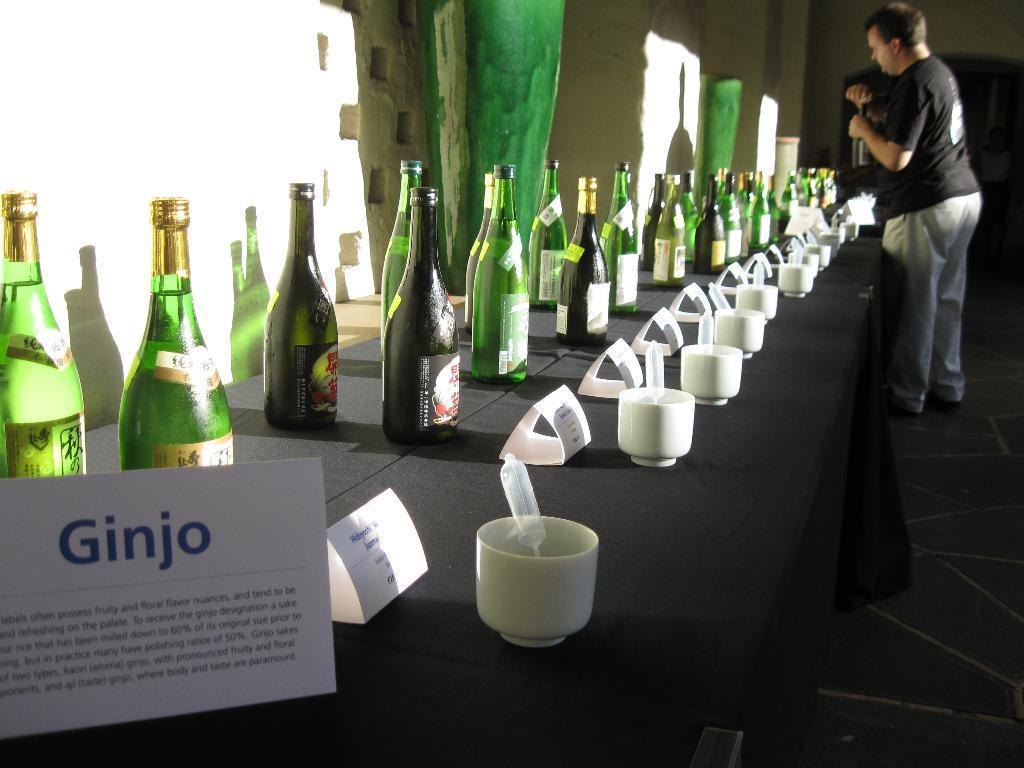In one or two sentences, can you explain what this image depicts? As we can see in the image, there is a white color wall, bottles and cups on table and there is a man standing on floor. 